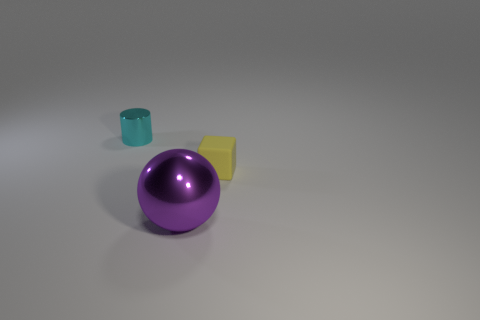Add 3 tiny purple balls. How many objects exist? 6 Subtract all large green things. Subtract all big purple metallic things. How many objects are left? 2 Add 2 metal things. How many metal things are left? 4 Add 1 tiny cyan things. How many tiny cyan things exist? 2 Subtract 0 brown cubes. How many objects are left? 3 Subtract all cubes. How many objects are left? 2 